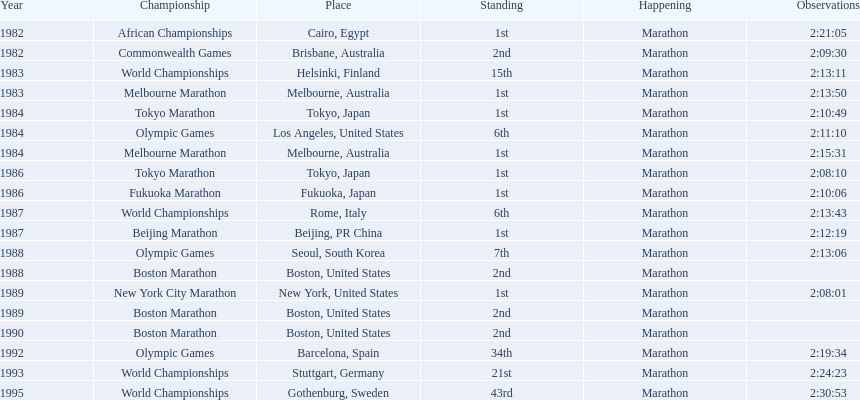What are the competitions? African Championships, Cairo, Egypt, Commonwealth Games, Brisbane, Australia, World Championships, Helsinki, Finland, Melbourne Marathon, Melbourne, Australia, Tokyo Marathon, Tokyo, Japan, Olympic Games, Los Angeles, United States, Melbourne Marathon, Melbourne, Australia, Tokyo Marathon, Tokyo, Japan, Fukuoka Marathon, Fukuoka, Japan, World Championships, Rome, Italy, Beijing Marathon, Beijing, PR China, Olympic Games, Seoul, South Korea, Boston Marathon, Boston, United States, New York City Marathon, New York, United States, Boston Marathon, Boston, United States, Boston Marathon, Boston, United States, Olympic Games, Barcelona, Spain, World Championships, Stuttgart, Germany, World Championships, Gothenburg, Sweden. Which ones occured in china? Beijing Marathon, Beijing, PR China. Which one is it? Beijing Marathon. 